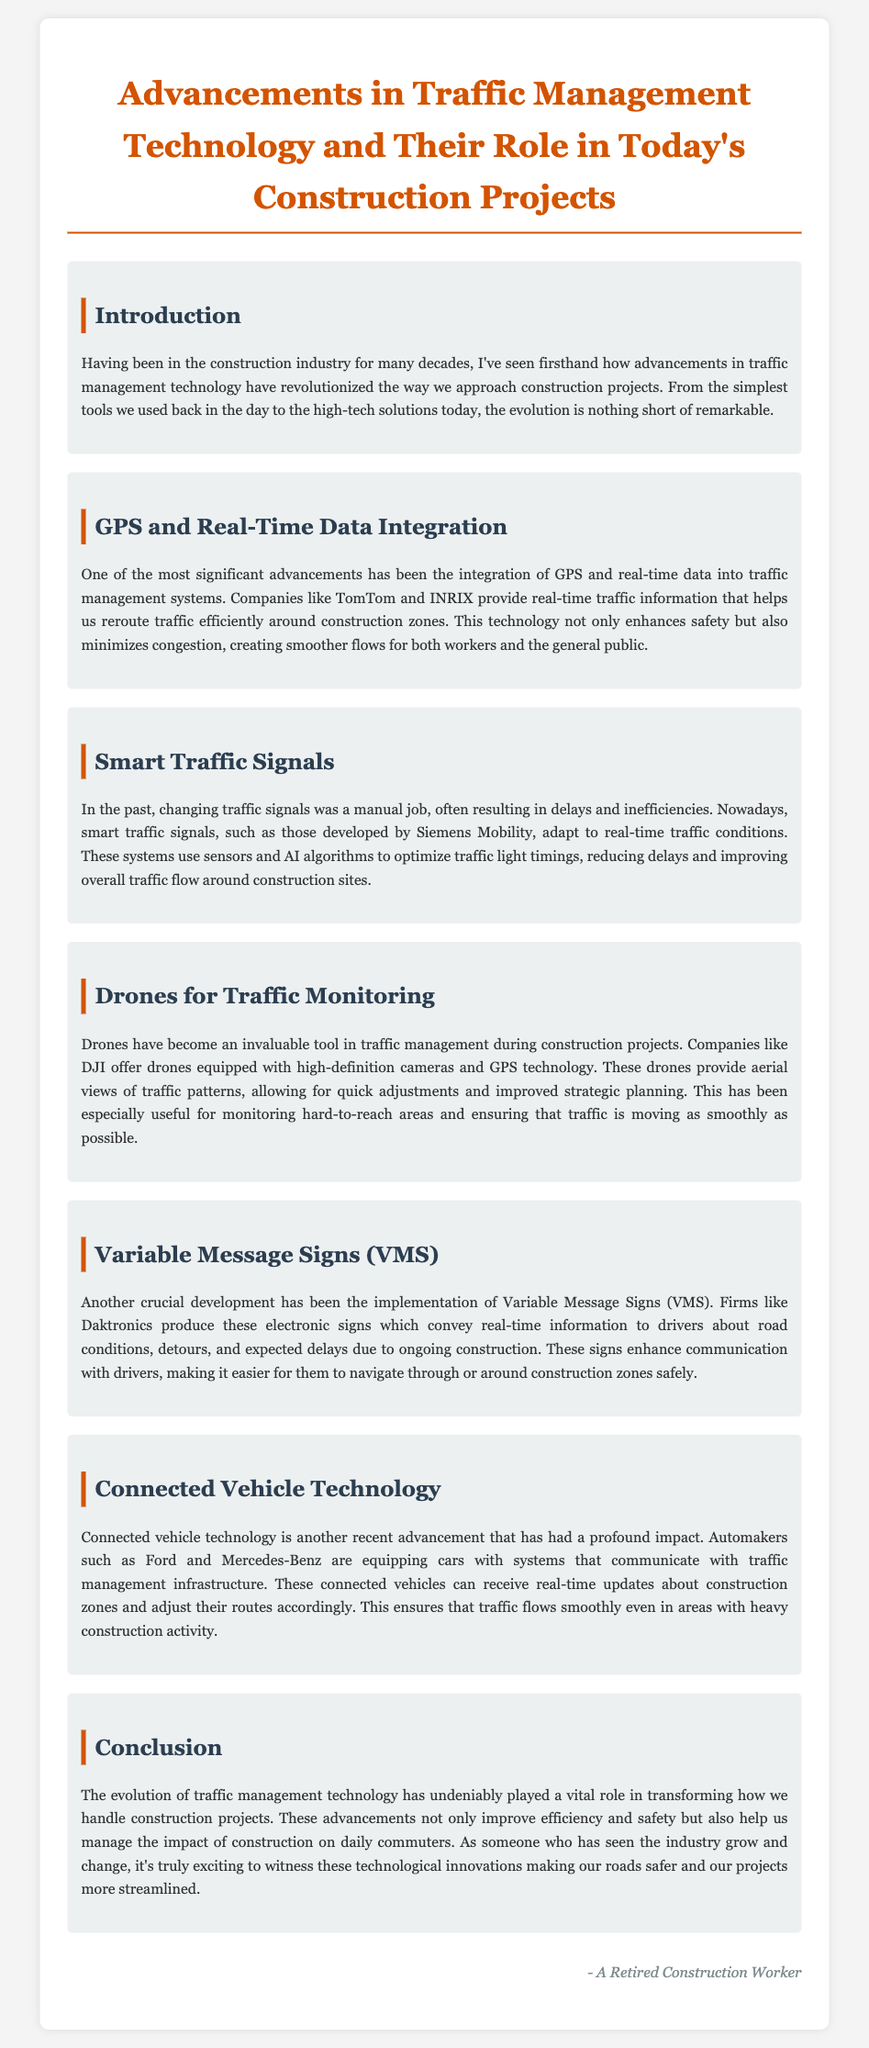What technology helps reroute traffic around construction zones? The document mentions GPS and real-time data integration as the technology that helps reroute traffic efficiently around construction zones.
Answer: GPS and real-time data integration Which company produces smart traffic signals? Siemens Mobility is identified in the document as the company that develops smart traffic signals.
Answer: Siemens Mobility What tool is used for traffic monitoring during construction projects? Drones, specifically those offered by DJI, are highlighted as invaluable tools for traffic monitoring.
Answer: Drones What do Variable Message Signs communicate? The document states that Variable Message Signs convey real-time information to drivers regarding road conditions, detours, and delays due to construction.
Answer: Real-time information Which automakers are mentioned in connection with connected vehicle technology? Ford and Mercedes-Benz are specified in the document as automakers equipping cars with connected vehicle technology.
Answer: Ford and Mercedes-Benz How do smart traffic signals improve traffic flow? The document explains that smart traffic signals use sensors and AI algorithms to optimize traffic light timings, improving overall traffic flow.
Answer: Optimize traffic light timings What impact have technological advancements had on construction project efficiency? The document concludes that advancements in traffic management technology improve efficiency and safety, helping to manage construction's impact on commuters.
Answer: Improve efficiency and safety What are the benefits of drones mentioned in the report? Drones provide aerial views of traffic patterns and allow for quick adjustments in traffic management.
Answer: Aerial views and quick adjustments What is the purpose of connected vehicle technology? Connected vehicle technology allows vehicles to receive real-time updates about construction zones to ensure smooth traffic flow.
Answer: Real-time updates 